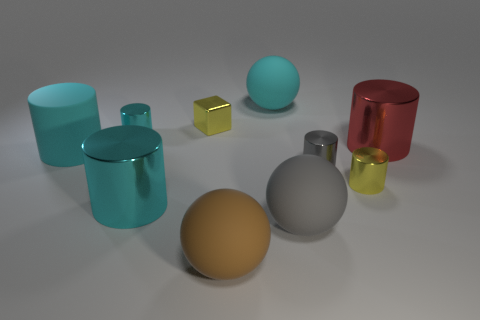There is a cyan rubber thing that is the same shape as the big gray object; what is its size?
Offer a terse response. Large. What shape is the object that is the same color as the shiny block?
Provide a short and direct response. Cylinder. Does the rubber ball that is left of the cyan ball have the same color as the large metallic cylinder that is on the left side of the brown thing?
Give a very brief answer. No. There is a gray shiny cylinder; what number of big objects are in front of it?
Provide a short and direct response. 3. The matte sphere that is the same color as the rubber cylinder is what size?
Offer a very short reply. Large. Are there any other gray objects of the same shape as the gray shiny object?
Keep it short and to the point. No. There is a shiny cylinder that is the same size as the red thing; what color is it?
Your answer should be compact. Cyan. Are there fewer tiny yellow metallic cylinders to the left of the big brown rubber sphere than cyan shiny things that are in front of the big cyan shiny thing?
Your response must be concise. No. There is a sphere that is on the left side of the cyan matte sphere; is its size the same as the small gray object?
Your response must be concise. No. What is the shape of the cyan matte thing that is to the right of the small yellow block?
Your answer should be compact. Sphere. 